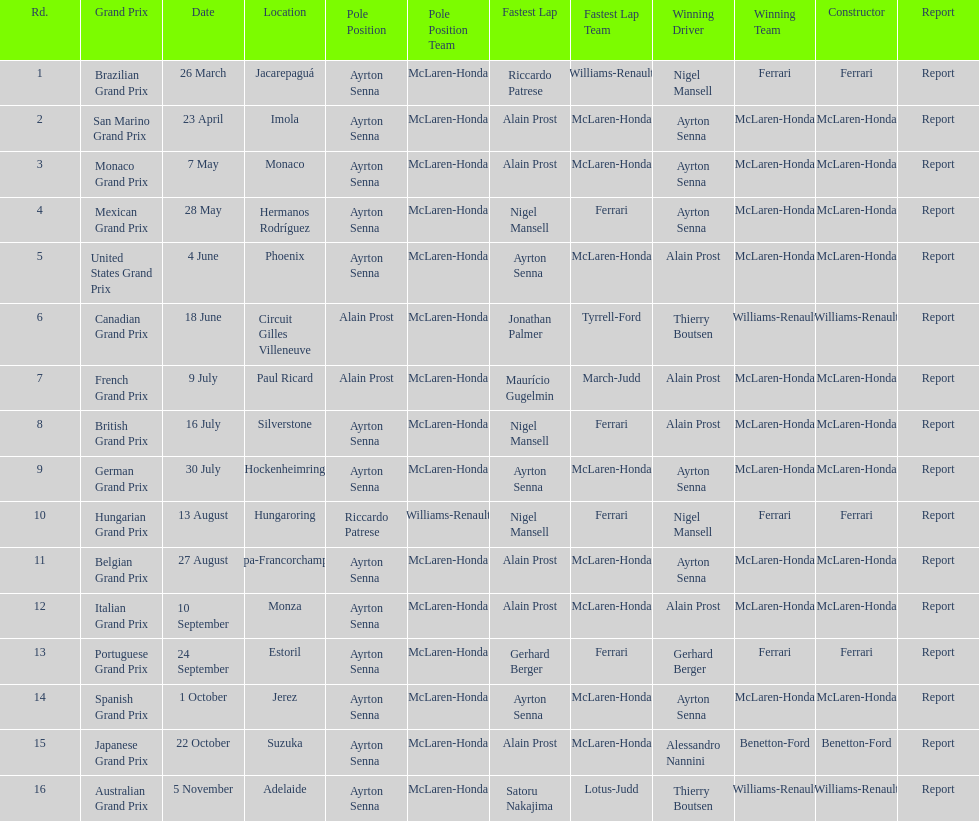What grand prix was before the san marino grand prix? Brazilian Grand Prix. 